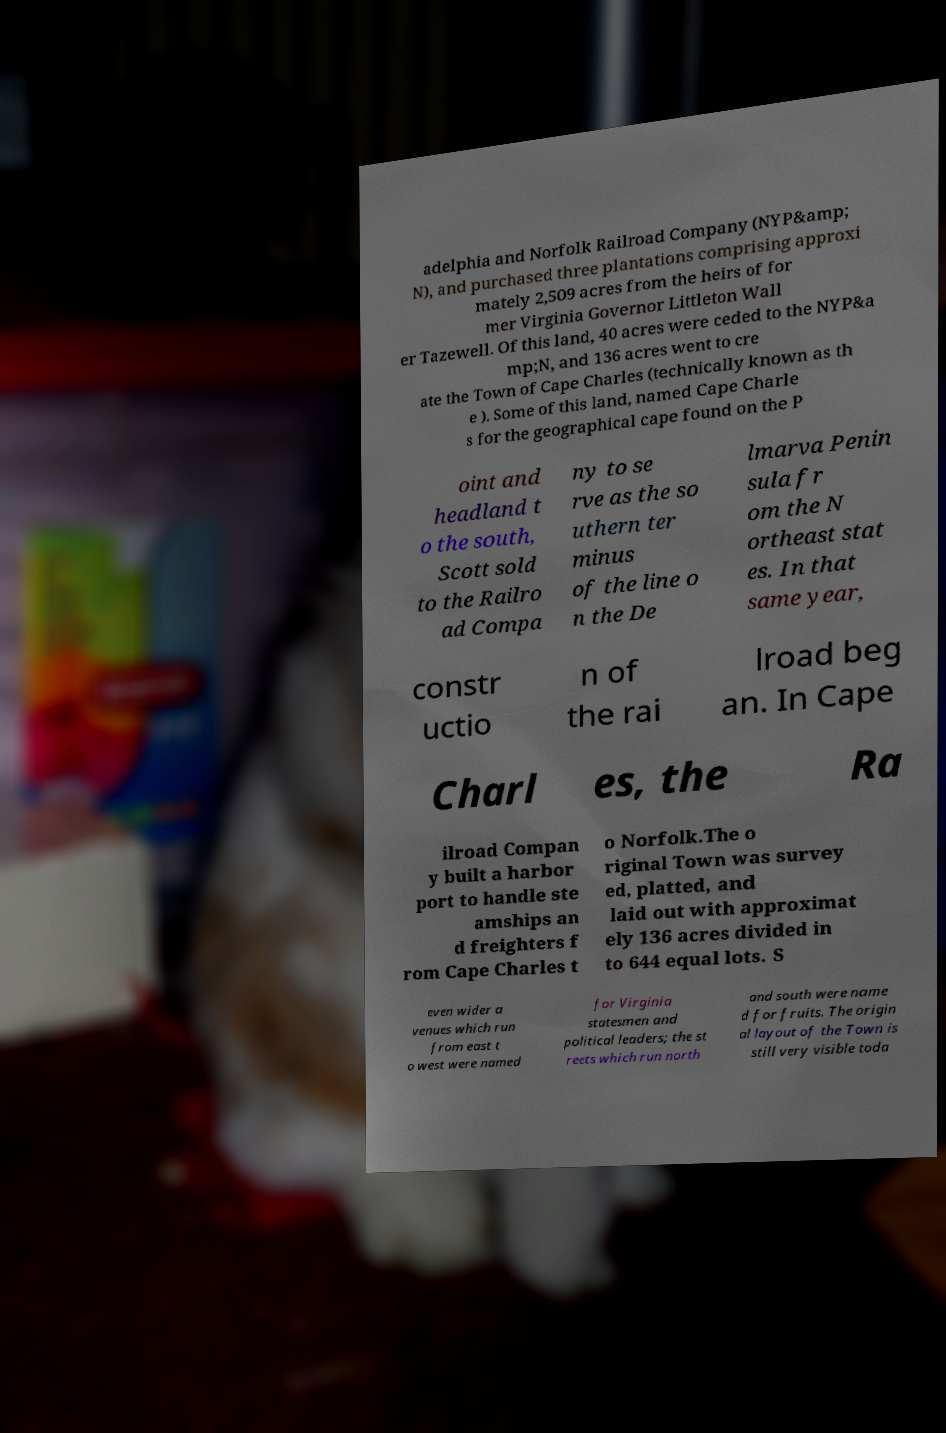Can you accurately transcribe the text from the provided image for me? adelphia and Norfolk Railroad Company (NYP&amp; N), and purchased three plantations comprising approxi mately 2,509 acres from the heirs of for mer Virginia Governor Littleton Wall er Tazewell. Of this land, 40 acres were ceded to the NYP&a mp;N, and 136 acres went to cre ate the Town of Cape Charles (technically known as th e ). Some of this land, named Cape Charle s for the geographical cape found on the P oint and headland t o the south, Scott sold to the Railro ad Compa ny to se rve as the so uthern ter minus of the line o n the De lmarva Penin sula fr om the N ortheast stat es. In that same year, constr uctio n of the rai lroad beg an. In Cape Charl es, the Ra ilroad Compan y built a harbor port to handle ste amships an d freighters f rom Cape Charles t o Norfolk.The o riginal Town was survey ed, platted, and laid out with approximat ely 136 acres divided in to 644 equal lots. S even wider a venues which run from east t o west were named for Virginia statesmen and political leaders; the st reets which run north and south were name d for fruits. The origin al layout of the Town is still very visible toda 